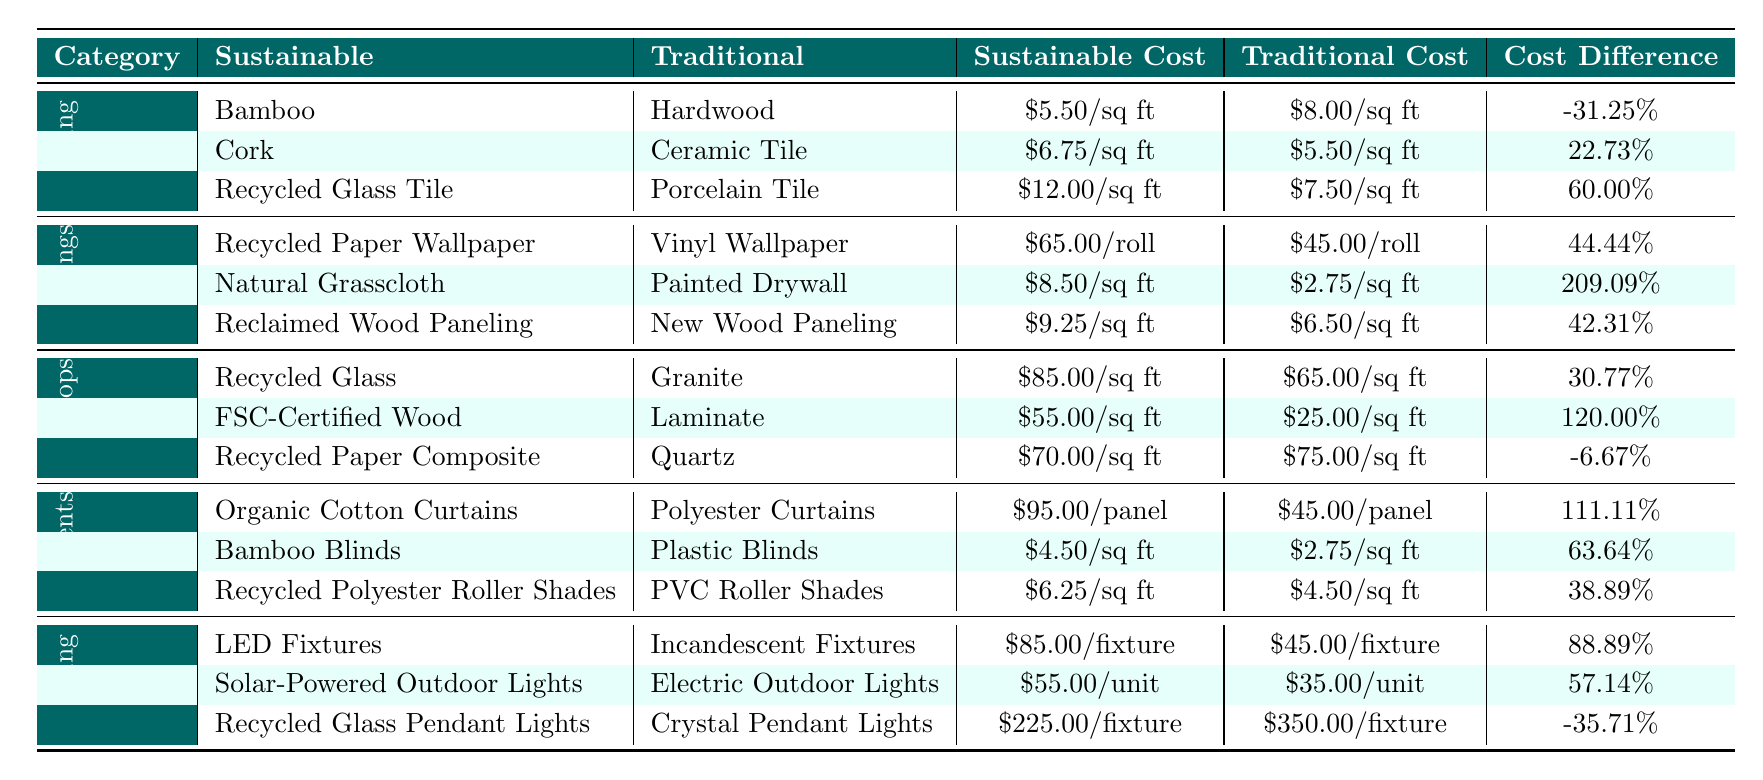What is the cost difference percentage between Bamboo and Hardwood flooring? The cost of Bamboo is $5.50/sq ft and Hardwood is $8.00/sq ft. The cost difference percentage is calculated as ((5.50 - 8.00) / 8.00) * 100 = -31.25%.
Answer: -31.25% Which sustainable material for flooring has a higher cost compared to its traditional counterpart? By looking at the flooring materials, Cork ($6.75/sq ft) is more expensive than Ceramic Tile ($5.50/sq ft). Recycled Glass Tile is also more expensive than Porcelain Tile.
Answer: Cork and Recycled Glass Tile What is the cost for Recycled Paper Composite and Quartz countertops? The cost for Recycled Paper Composite is $70.00/sq ft and Quartz is $75.00/sq ft.
Answer: $70.00/sq ft and $75.00/sq ft Which wall covering has the highest cost difference percentage? The highest cost difference percentage among wall coverings is for Natural Grasscloth compared to Painted Drywall, which is 209.09%.
Answer: 209.09% Are Organic Cotton Curtains cheaper than Polyester Curtains? The cost of Organic Cotton Curtains is $95.00/panel, while Polyester Curtains are $45.00/panel. Thus, Organic Cotton Curtains are not cheaper.
Answer: No What is the average sustainable cost of the window treatment materials? The sustainable costs for window treatments are $95.00/panel, $4.50/sq ft, and $6.25/sq ft. Converting all to the same unit (let's use the panel for calculations), assume 1 panel = 20 sq ft for the last two: $4.50 * 20 = $90.00/panel and $6.25 * 20 = $125.00/panel. The average is ($95.00 + $90.00 + $125.00) / 3 = $103.33/panel.
Answer: $103.33/panel How do the costs of sustainable Lighting fixtures compare to Traditional ones? The costs of sustainable Lighting fixtures (e.g., LED Fixtures) are all higher than their traditional counterparts (e.g., Incandescent Fixtures), except for the Recycled Glass Pendant Lights which have a lower cost than Crystal Pendant Lights. Overall, most sustainable options are more expensive.
Answer: Mostly higher, except one What is the total cost difference percentage for all the materials listed under Countertops? The cost differences for Countertops are 30.77%, 120.00%, and -6.67%. The total is 30.77 + 120.00 - 6.67 = 144.10%. Divide by 3 materials gives us an average percentage of 48.03%.
Answer: 48.03% 